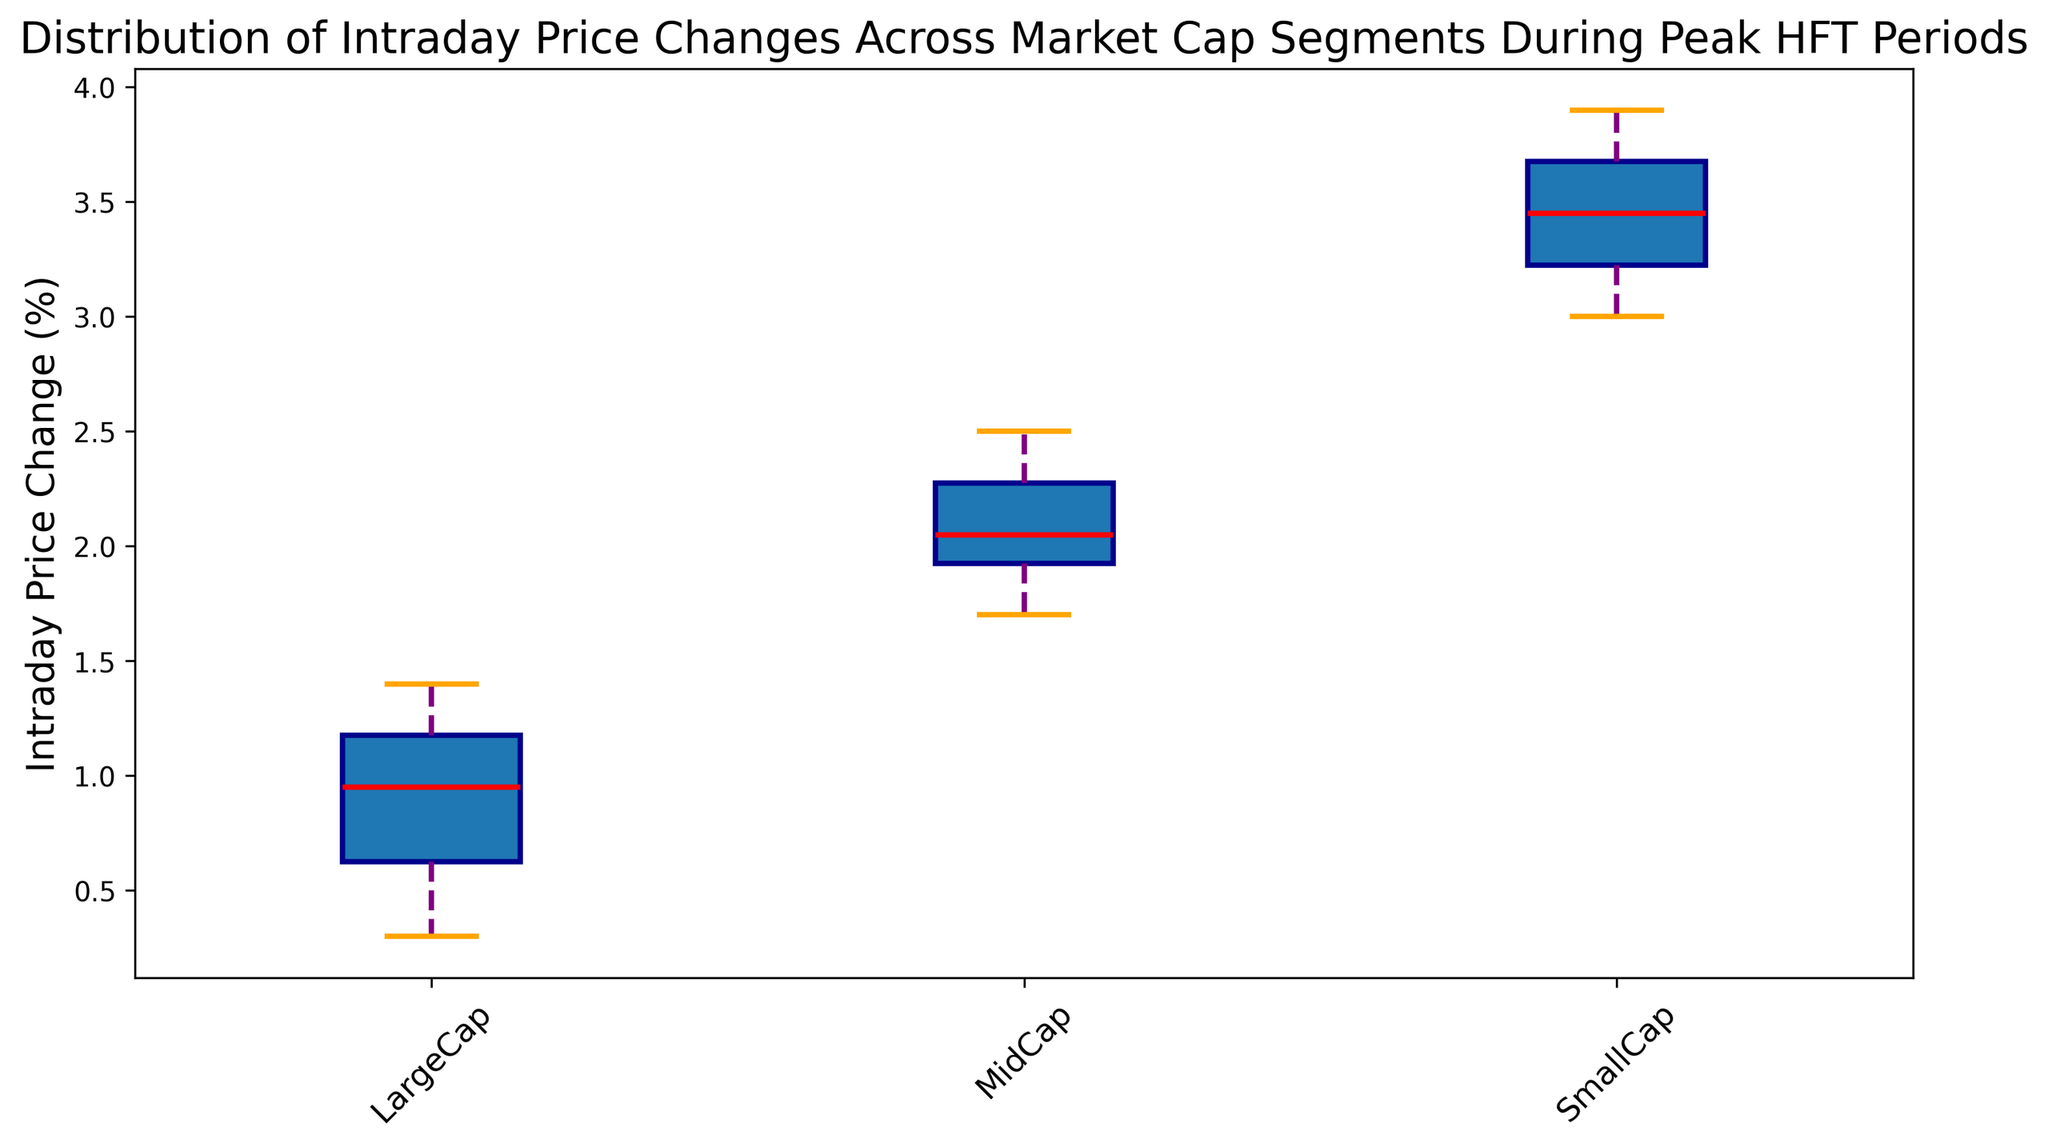What is the median intraday price change for LargeCap stocks? To find the median for LargeCap, locate the middle value of the sorted intraday price changes. Since there are 10 data points, the median will be the average of the 5th and 6th values.
Answer: 0.8 Which market cap segment has the highest median intraday price change? By visually comparing the median lines (red) of the box plots, the highest median line can be identified. In this case, it is the SmallCap segment.
Answer: SmallCap How does the variability in intraday price change differ between LargeCap and SmallCap stocks? To assess the variability, compare the size of the interquartile ranges (the boxes in the box plots) and the length of the whiskers of LargeCap and SmallCap segments. SmallCap shows higher variability as both the interquartile range and the whiskers are larger compared to LargeCap.
Answer: SmallCap has higher variability What is the range of intraday price changes for MidCap stocks? The range is the difference between the maximum and minimum values. For MidCap, visually estimate the highest and lowest points of the whiskers. The maximum is approximately 2.5, and the minimum is about 1.7. Thus, the range is 2.5 - 1.7.
Answer: 0.8 Are there any outliers in the LargeCap segment? Outliers are shown as individual points outside the whiskers. Visually inspect the box plot for LargeCap, but there are no separate points outside the whiskers in this case.
Answer: No Comparing the median intraday price changes, which segment lies between the other two segments in value? Compare the red median lines of all three segments. The MidCap segment has a median value that lies between the medians of the LargeCap and SmallCap segments.
Answer: MidCap What is the interquartile range (IQR) of intraday price changes for SmallCap stocks? To find the IQR, subtract the first quartile (bottom of the box) from the third quartile (top of the box). Visually, for SmallCap, the first quartile is around 3.2 and the third quartile is around 3.6, so the IQR is 3.6 - 3.2.
Answer: 0.4 Which segment exhibits the smallest interquartile range (IQR)? Visually compare the lengths of the boxes (the interquartile ranges) across the segments. The LargeCap segment has the smallest box, indicating the smallest IQR.
Answer: LargeCap 